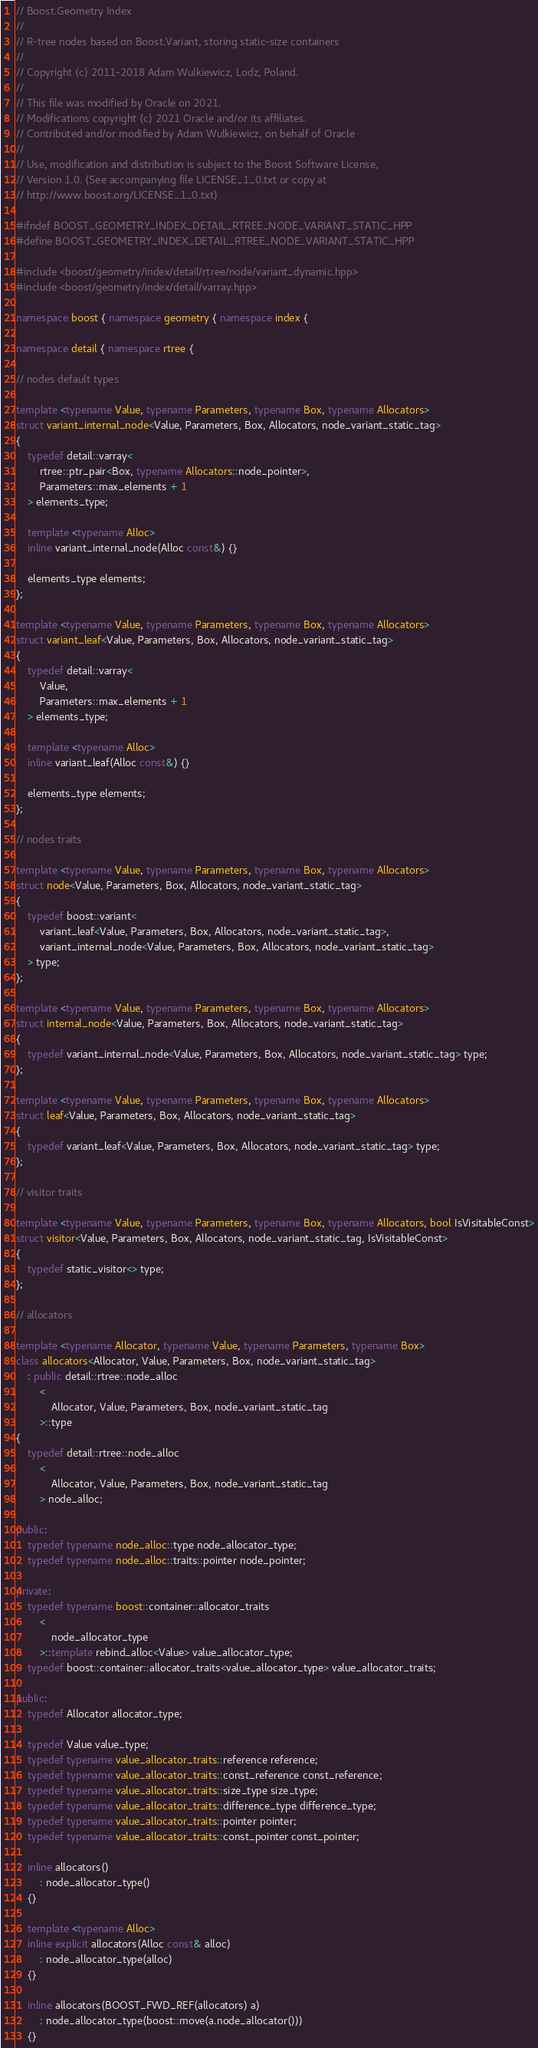<code> <loc_0><loc_0><loc_500><loc_500><_C++_>// Boost.Geometry Index
//
// R-tree nodes based on Boost.Variant, storing static-size containers
//
// Copyright (c) 2011-2018 Adam Wulkiewicz, Lodz, Poland.
//
// This file was modified by Oracle on 2021.
// Modifications copyright (c) 2021 Oracle and/or its affiliates.
// Contributed and/or modified by Adam Wulkiewicz, on behalf of Oracle
//
// Use, modification and distribution is subject to the Boost Software License,
// Version 1.0. (See accompanying file LICENSE_1_0.txt or copy at
// http://www.boost.org/LICENSE_1_0.txt)

#ifndef BOOST_GEOMETRY_INDEX_DETAIL_RTREE_NODE_VARIANT_STATIC_HPP
#define BOOST_GEOMETRY_INDEX_DETAIL_RTREE_NODE_VARIANT_STATIC_HPP

#include <boost/geometry/index/detail/rtree/node/variant_dynamic.hpp>
#include <boost/geometry/index/detail/varray.hpp>

namespace boost { namespace geometry { namespace index {

namespace detail { namespace rtree {

// nodes default types

template <typename Value, typename Parameters, typename Box, typename Allocators>
struct variant_internal_node<Value, Parameters, Box, Allocators, node_variant_static_tag>
{
    typedef detail::varray<
        rtree::ptr_pair<Box, typename Allocators::node_pointer>,
        Parameters::max_elements + 1
    > elements_type;

    template <typename Alloc>
    inline variant_internal_node(Alloc const&) {}

    elements_type elements;
};

template <typename Value, typename Parameters, typename Box, typename Allocators>
struct variant_leaf<Value, Parameters, Box, Allocators, node_variant_static_tag>
{
    typedef detail::varray<
        Value,
        Parameters::max_elements + 1
    > elements_type;

    template <typename Alloc>
    inline variant_leaf(Alloc const&) {}

    elements_type elements;
};

// nodes traits

template <typename Value, typename Parameters, typename Box, typename Allocators>
struct node<Value, Parameters, Box, Allocators, node_variant_static_tag>
{
    typedef boost::variant<
        variant_leaf<Value, Parameters, Box, Allocators, node_variant_static_tag>,
        variant_internal_node<Value, Parameters, Box, Allocators, node_variant_static_tag>
    > type;
};

template <typename Value, typename Parameters, typename Box, typename Allocators>
struct internal_node<Value, Parameters, Box, Allocators, node_variant_static_tag>
{
    typedef variant_internal_node<Value, Parameters, Box, Allocators, node_variant_static_tag> type;
};

template <typename Value, typename Parameters, typename Box, typename Allocators>
struct leaf<Value, Parameters, Box, Allocators, node_variant_static_tag>
{
    typedef variant_leaf<Value, Parameters, Box, Allocators, node_variant_static_tag> type;
};

// visitor traits

template <typename Value, typename Parameters, typename Box, typename Allocators, bool IsVisitableConst>
struct visitor<Value, Parameters, Box, Allocators, node_variant_static_tag, IsVisitableConst>
{
    typedef static_visitor<> type;
};

// allocators

template <typename Allocator, typename Value, typename Parameters, typename Box>
class allocators<Allocator, Value, Parameters, Box, node_variant_static_tag>
    : public detail::rtree::node_alloc
        <
            Allocator, Value, Parameters, Box, node_variant_static_tag
        >::type
{
    typedef detail::rtree::node_alloc
        <
            Allocator, Value, Parameters, Box, node_variant_static_tag
        > node_alloc;

public:
    typedef typename node_alloc::type node_allocator_type;
    typedef typename node_alloc::traits::pointer node_pointer;

private:
    typedef typename boost::container::allocator_traits
        <
            node_allocator_type
        >::template rebind_alloc<Value> value_allocator_type;
    typedef boost::container::allocator_traits<value_allocator_type> value_allocator_traits;

public:
    typedef Allocator allocator_type;

    typedef Value value_type;
    typedef typename value_allocator_traits::reference reference;
    typedef typename value_allocator_traits::const_reference const_reference;
    typedef typename value_allocator_traits::size_type size_type;
    typedef typename value_allocator_traits::difference_type difference_type;
    typedef typename value_allocator_traits::pointer pointer;
    typedef typename value_allocator_traits::const_pointer const_pointer;

    inline allocators()
        : node_allocator_type()
    {}

    template <typename Alloc>
    inline explicit allocators(Alloc const& alloc)
        : node_allocator_type(alloc)
    {}

    inline allocators(BOOST_FWD_REF(allocators) a)
        : node_allocator_type(boost::move(a.node_allocator()))
    {}
</code> 